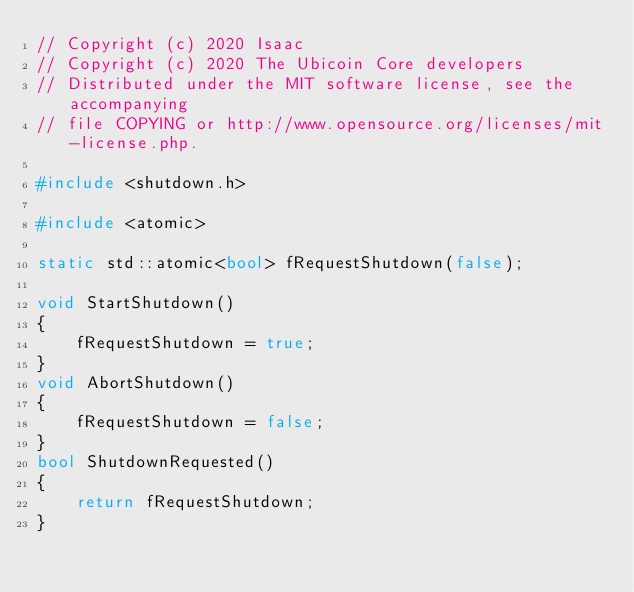<code> <loc_0><loc_0><loc_500><loc_500><_C++_>// Copyright (c) 2020 Isaac
// Copyright (c) 2020 The Ubicoin Core developers
// Distributed under the MIT software license, see the accompanying
// file COPYING or http://www.opensource.org/licenses/mit-license.php.

#include <shutdown.h>

#include <atomic>

static std::atomic<bool> fRequestShutdown(false);

void StartShutdown()
{
    fRequestShutdown = true;
}
void AbortShutdown()
{
    fRequestShutdown = false;
}
bool ShutdownRequested()
{
    return fRequestShutdown;
}
</code> 